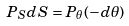<formula> <loc_0><loc_0><loc_500><loc_500>P _ { S } d S = P _ { \theta } ( - d \theta )</formula> 